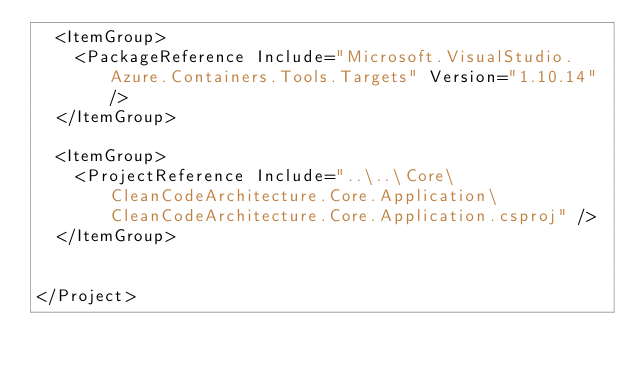<code> <loc_0><loc_0><loc_500><loc_500><_XML_>  <ItemGroup>
    <PackageReference Include="Microsoft.VisualStudio.Azure.Containers.Tools.Targets" Version="1.10.14" />
  </ItemGroup>

  <ItemGroup>
    <ProjectReference Include="..\..\Core\CleanCodeArchitecture.Core.Application\CleanCodeArchitecture.Core.Application.csproj" />
  </ItemGroup>


</Project>
</code> 